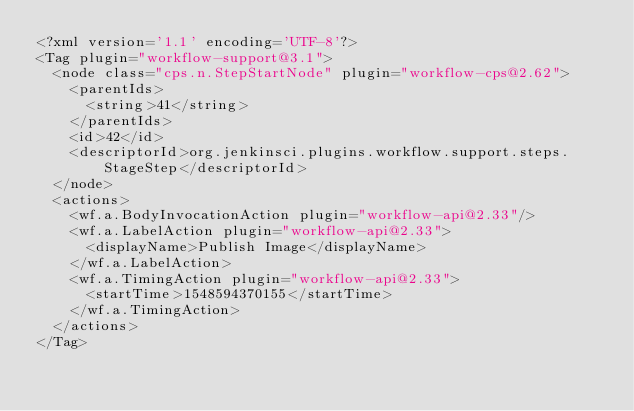Convert code to text. <code><loc_0><loc_0><loc_500><loc_500><_XML_><?xml version='1.1' encoding='UTF-8'?>
<Tag plugin="workflow-support@3.1">
  <node class="cps.n.StepStartNode" plugin="workflow-cps@2.62">
    <parentIds>
      <string>41</string>
    </parentIds>
    <id>42</id>
    <descriptorId>org.jenkinsci.plugins.workflow.support.steps.StageStep</descriptorId>
  </node>
  <actions>
    <wf.a.BodyInvocationAction plugin="workflow-api@2.33"/>
    <wf.a.LabelAction plugin="workflow-api@2.33">
      <displayName>Publish Image</displayName>
    </wf.a.LabelAction>
    <wf.a.TimingAction plugin="workflow-api@2.33">
      <startTime>1548594370155</startTime>
    </wf.a.TimingAction>
  </actions>
</Tag></code> 